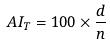<formula> <loc_0><loc_0><loc_500><loc_500>A I _ { T } = 1 0 0 \times \frac { d } { n }</formula> 